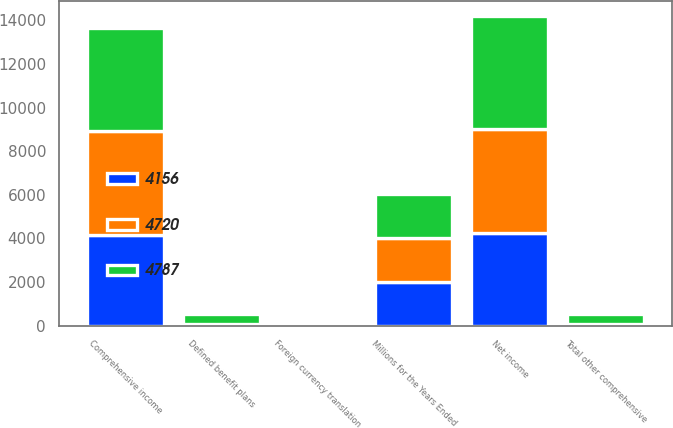<chart> <loc_0><loc_0><loc_500><loc_500><stacked_bar_chart><ecel><fcel>Millions for the Years Ended<fcel>Net income<fcel>Defined benefit plans<fcel>Foreign currency translation<fcel>Total other comprehensive<fcel>Comprehensive income<nl><fcel>4156<fcel>2016<fcel>4233<fcel>29<fcel>48<fcel>77<fcel>4156<nl><fcel>4720<fcel>2015<fcel>4772<fcel>58<fcel>43<fcel>15<fcel>4787<nl><fcel>4787<fcel>2014<fcel>5180<fcel>448<fcel>12<fcel>460<fcel>4720<nl></chart> 